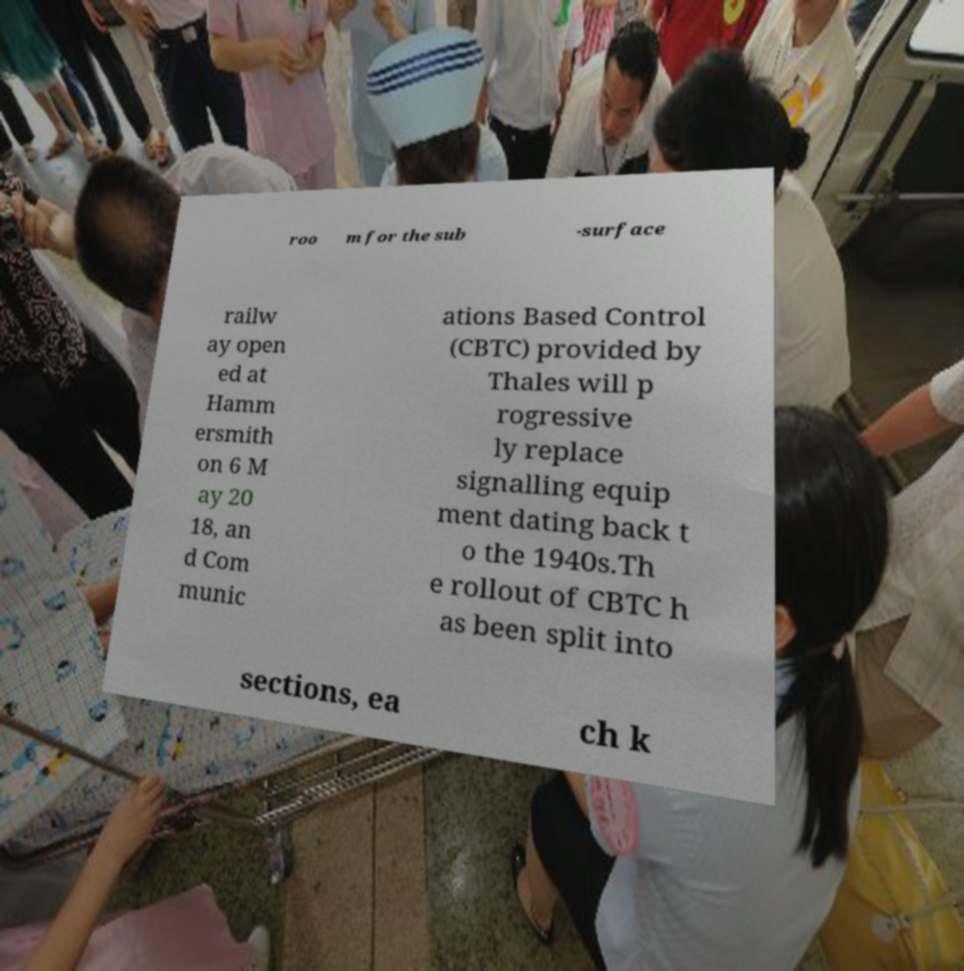Can you read and provide the text displayed in the image?This photo seems to have some interesting text. Can you extract and type it out for me? roo m for the sub -surface railw ay open ed at Hamm ersmith on 6 M ay 20 18, an d Com munic ations Based Control (CBTC) provided by Thales will p rogressive ly replace signalling equip ment dating back t o the 1940s.Th e rollout of CBTC h as been split into sections, ea ch k 